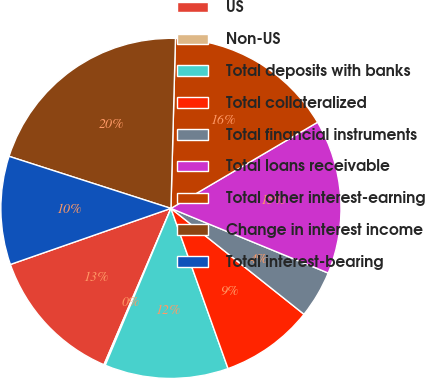Convert chart. <chart><loc_0><loc_0><loc_500><loc_500><pie_chart><fcel>US<fcel>Non-US<fcel>Total deposits with banks<fcel>Total collateralized<fcel>Total financial instruments<fcel>Total loans receivable<fcel>Total other interest-earning<fcel>Change in interest income<fcel>Total interest-bearing<nl><fcel>13.21%<fcel>0.13%<fcel>11.76%<fcel>8.85%<fcel>4.49%<fcel>14.66%<fcel>16.12%<fcel>20.47%<fcel>10.3%<nl></chart> 